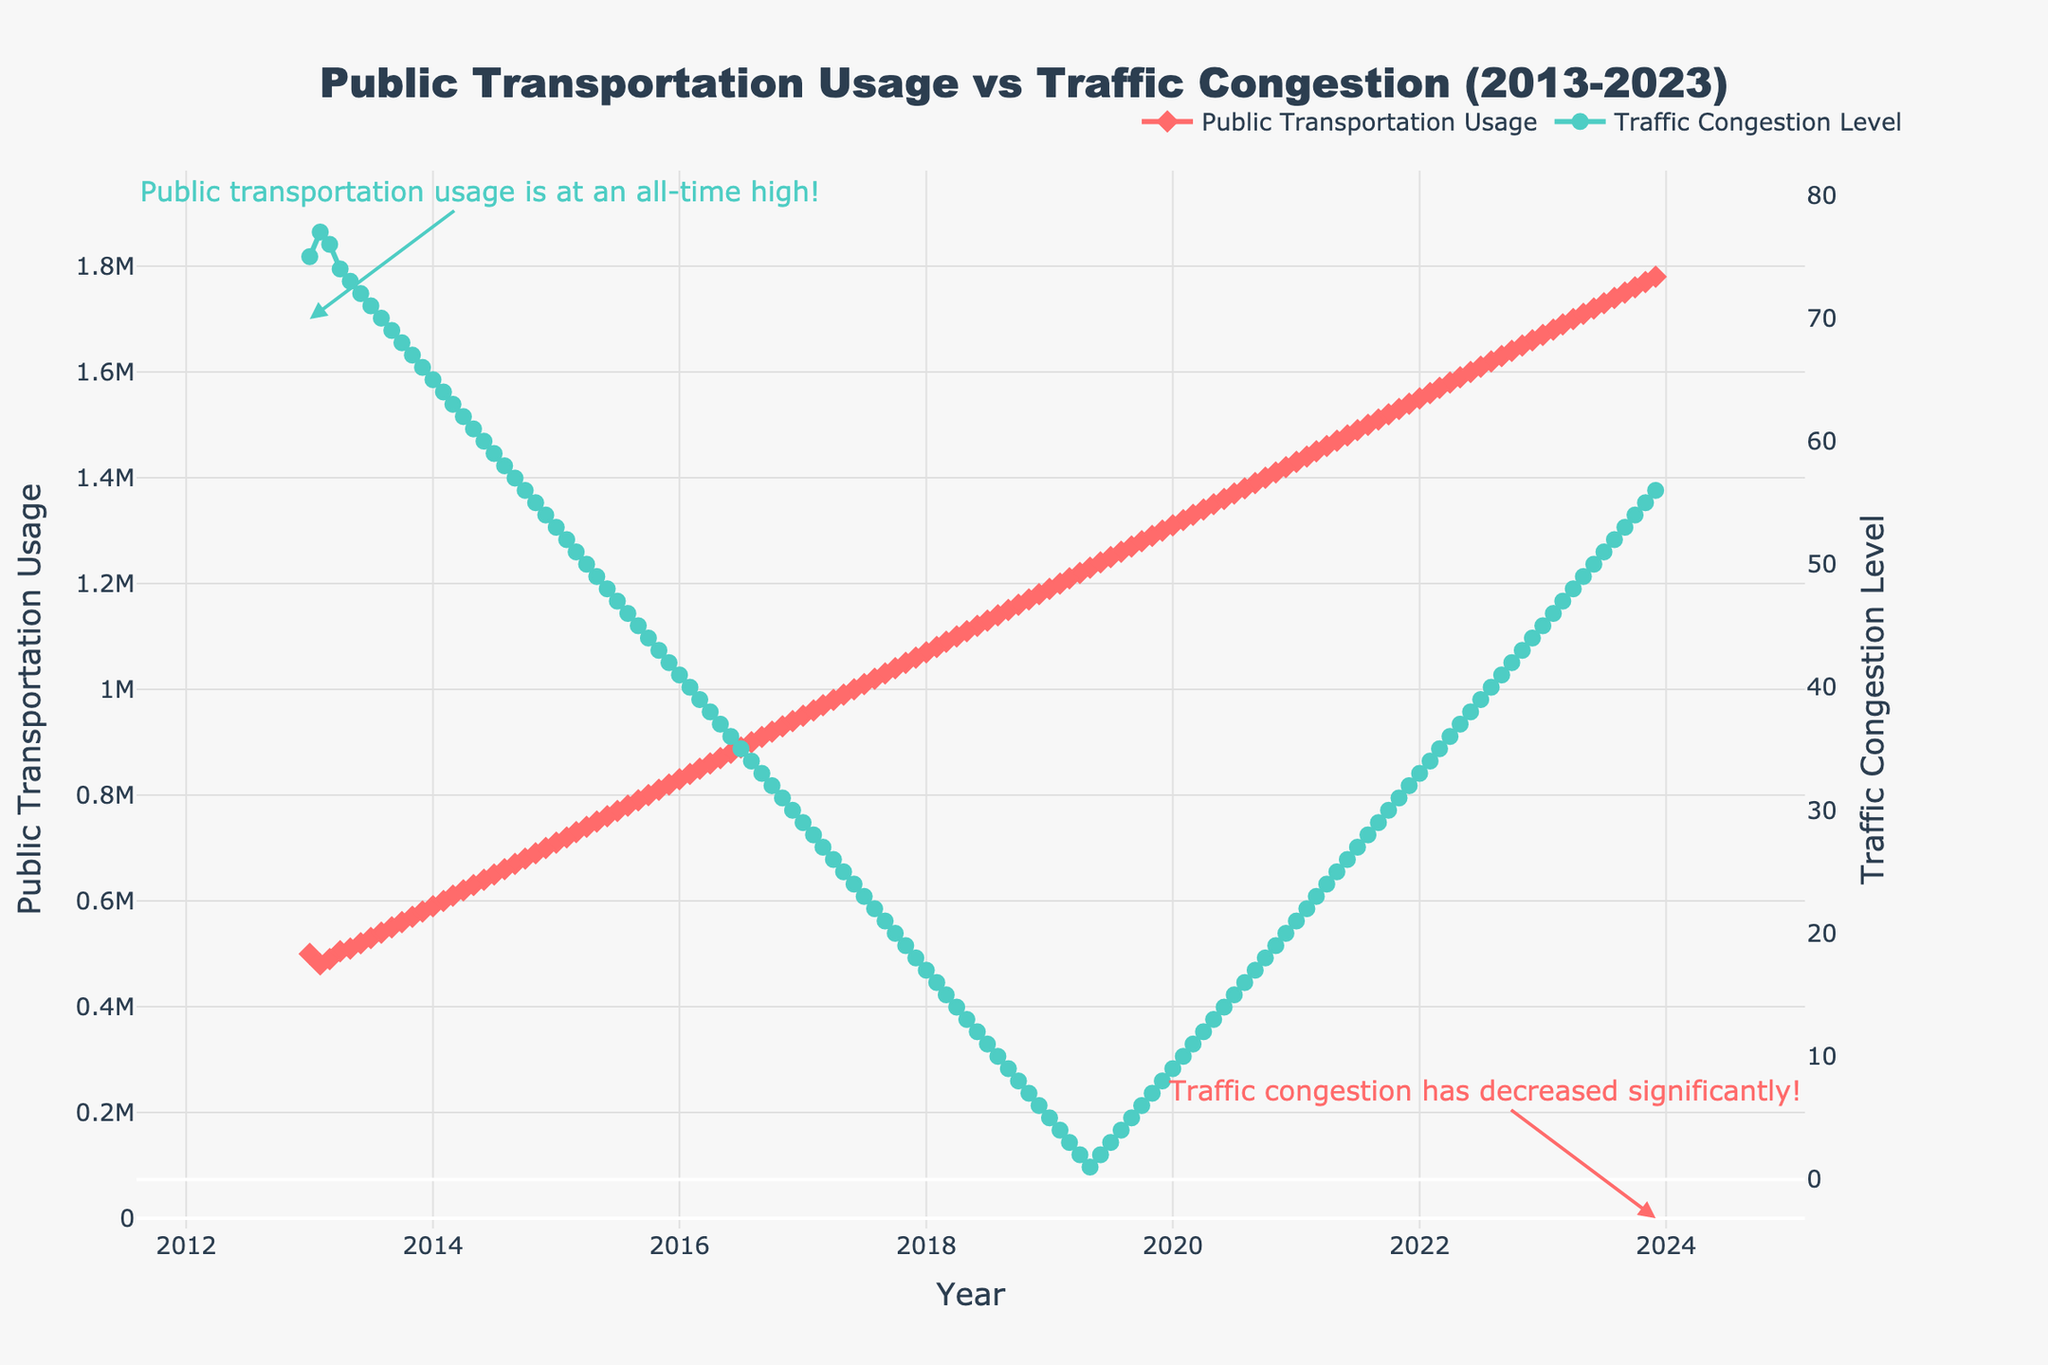What is the overall trend in public transportation usage from 2013 to 2023? The figure shows a continuous increase in public transportation usage from 2013 to 2023. Initially, the usage was around 500,000 in January 2013 and reached approximately 1,780,000 by December 2023.
Answer: Continuous increase How has the traffic congestion level changed over the last ten years? Over the ten-year period, traffic congestion has generally decreased. In January 2013, the congestion level was around 75, and it declined to about 56 by December 2023.
Answer: Decreased What's the title of the figure? The title is located at the top of the figure, stating "Public Transportation Usage vs Traffic Congestion (2013-2023)."
Answer: Public Transportation Usage vs Traffic Congestion (2013-2023) What does the annotation near December 2023 indicate? The annotation near December 2023 specifies that "Traffic congestion has decreased significantly!"
Answer: Traffic congestion has decreased significantly! What is the relationship between public transportation usage and traffic congestion from 2013 to 2023? The figure shows an inverse relationship between public transportation usage and traffic congestion over the years. As public transportation usage increased, traffic congestion levels decreased. For instance, as usage grew from 500,000 to 1,780,000, congestion dropped from 75 to 56.
Answer: Inverse relationship By how much did the public transportation usage increase from January 2013 to December 2023? The public transportation usage increased from 500,000 in January 2013 to 1,780,000 in December 2023. The difference is 1,780,000 - 500,000 = 1,280,000.
Answer: 1,280,000 Which year had the highest public transportation usage? The figure shows usage increasing year by year, with 2023 having the highest usage at approximately 1,780,000.
Answer: 2023 What pattern can be observed regarding traffic congestion levels in the later years, say 2019 onwards? From 2019 onwards, traffic congestion levels show some fluctuation but generally increased from the low seen in previous years. In 2019, monthly levels began at 5 and fluctuated until 2023 when it reached 56.
Answer: Fluctuation but generally increasing What is the congestion level in January 2020 compared to January 2013? In January 2013, the congestion level was around 75. In January 2020, it decreased to around 9. So, congestion in 2020 was much lower compared to 2013.
Answer: Lower in 2020 Is there any month where both public transportation usage and traffic congestion show a significant change? Yes, in January 2014, public transportation usage rose significantly from 580,000 in December 2013 to 590,000 and congestion dropped from 66 to 65, indicating a noticeable change.
Answer: January 2014 